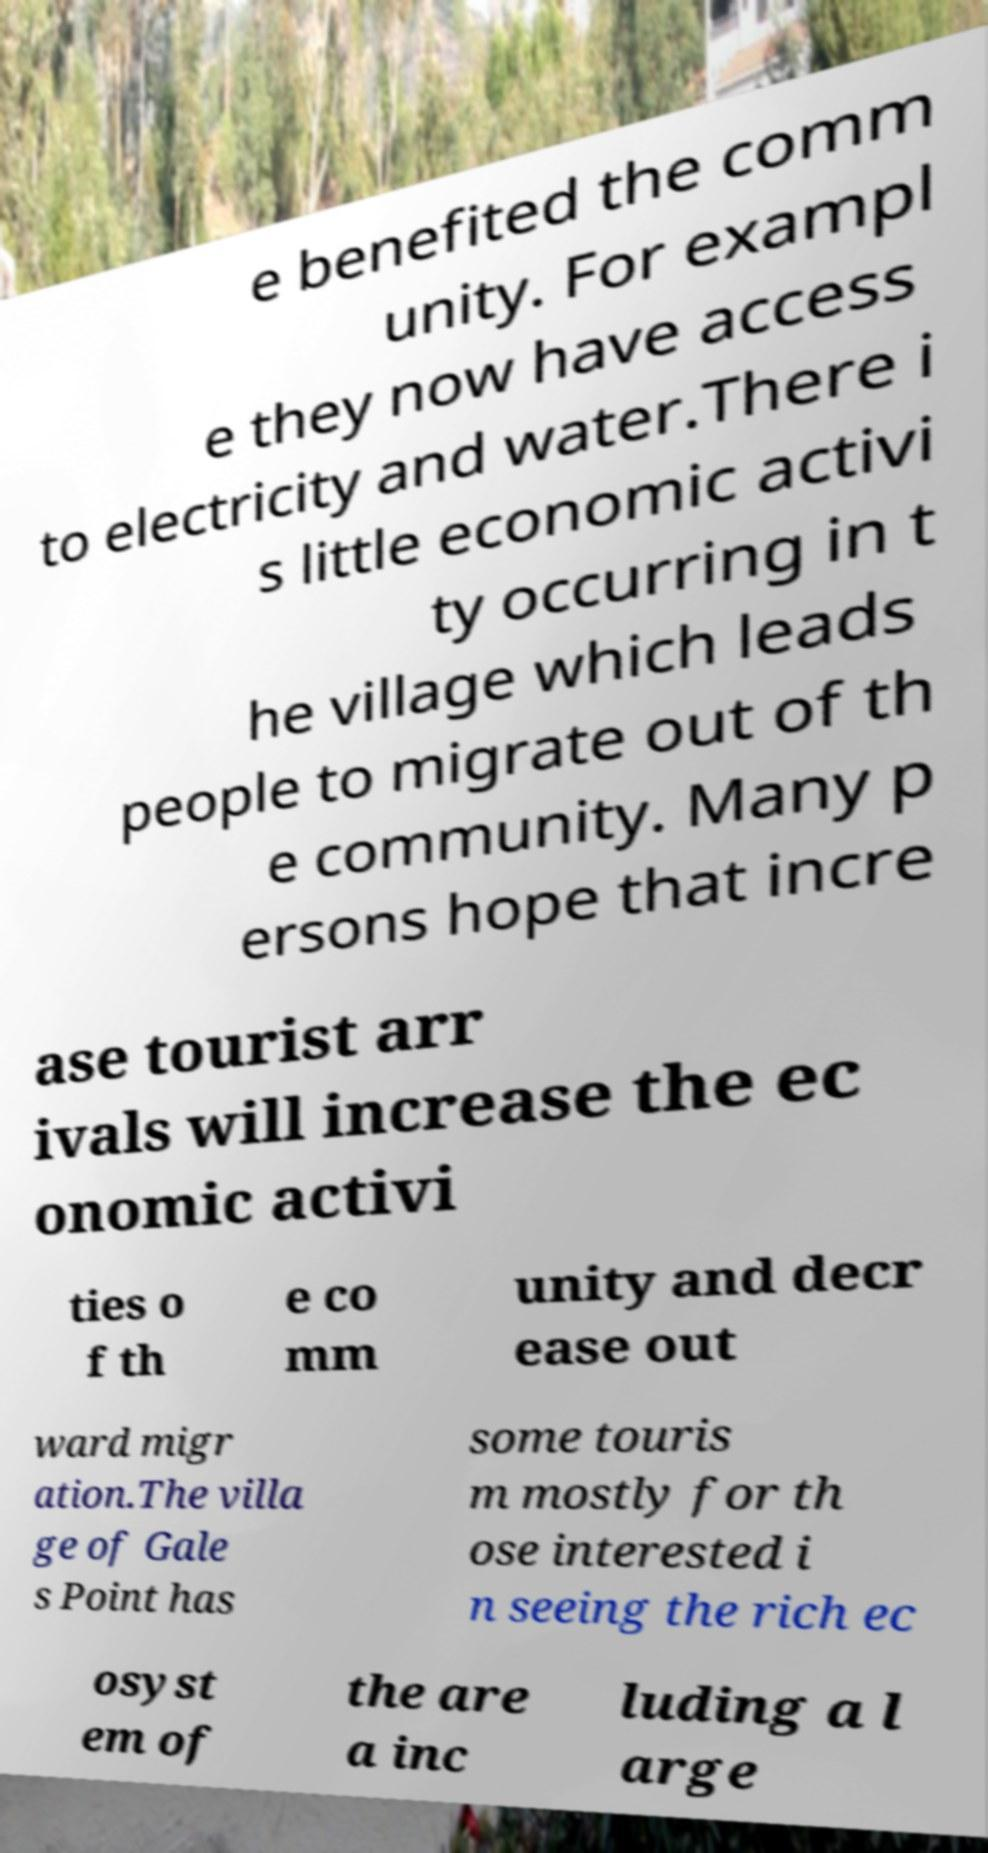Could you assist in decoding the text presented in this image and type it out clearly? e benefited the comm unity. For exampl e they now have access to electricity and water.There i s little economic activi ty occurring in t he village which leads people to migrate out of th e community. Many p ersons hope that incre ase tourist arr ivals will increase the ec onomic activi ties o f th e co mm unity and decr ease out ward migr ation.The villa ge of Gale s Point has some touris m mostly for th ose interested i n seeing the rich ec osyst em of the are a inc luding a l arge 